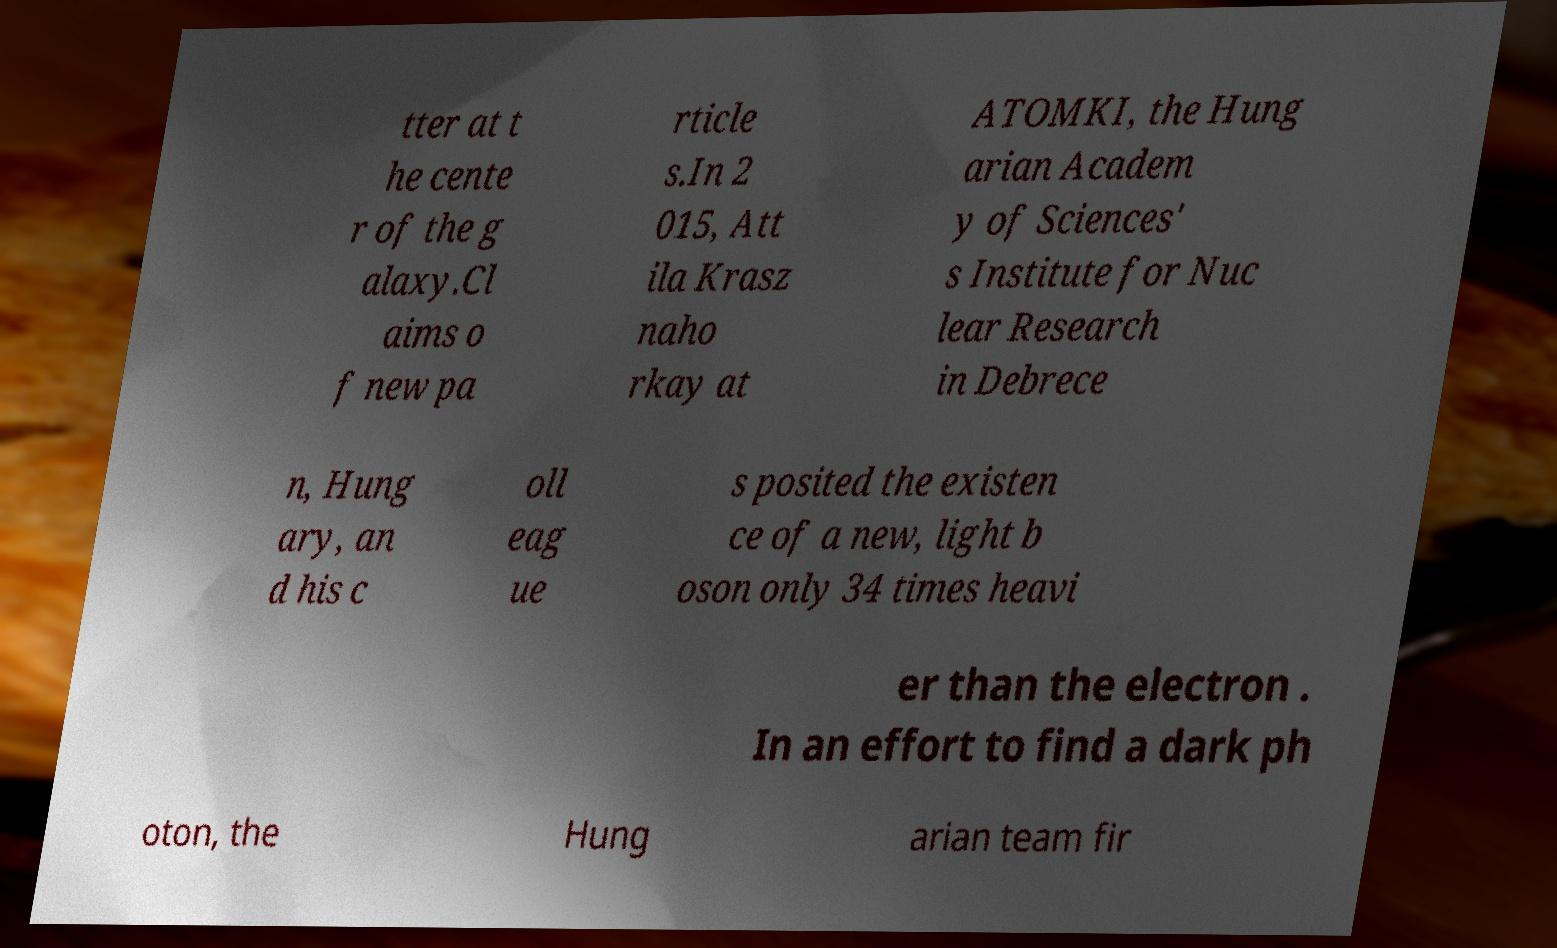Could you assist in decoding the text presented in this image and type it out clearly? tter at t he cente r of the g alaxy.Cl aims o f new pa rticle s.In 2 015, Att ila Krasz naho rkay at ATOMKI, the Hung arian Academ y of Sciences' s Institute for Nuc lear Research in Debrece n, Hung ary, an d his c oll eag ue s posited the existen ce of a new, light b oson only 34 times heavi er than the electron . In an effort to find a dark ph oton, the Hung arian team fir 